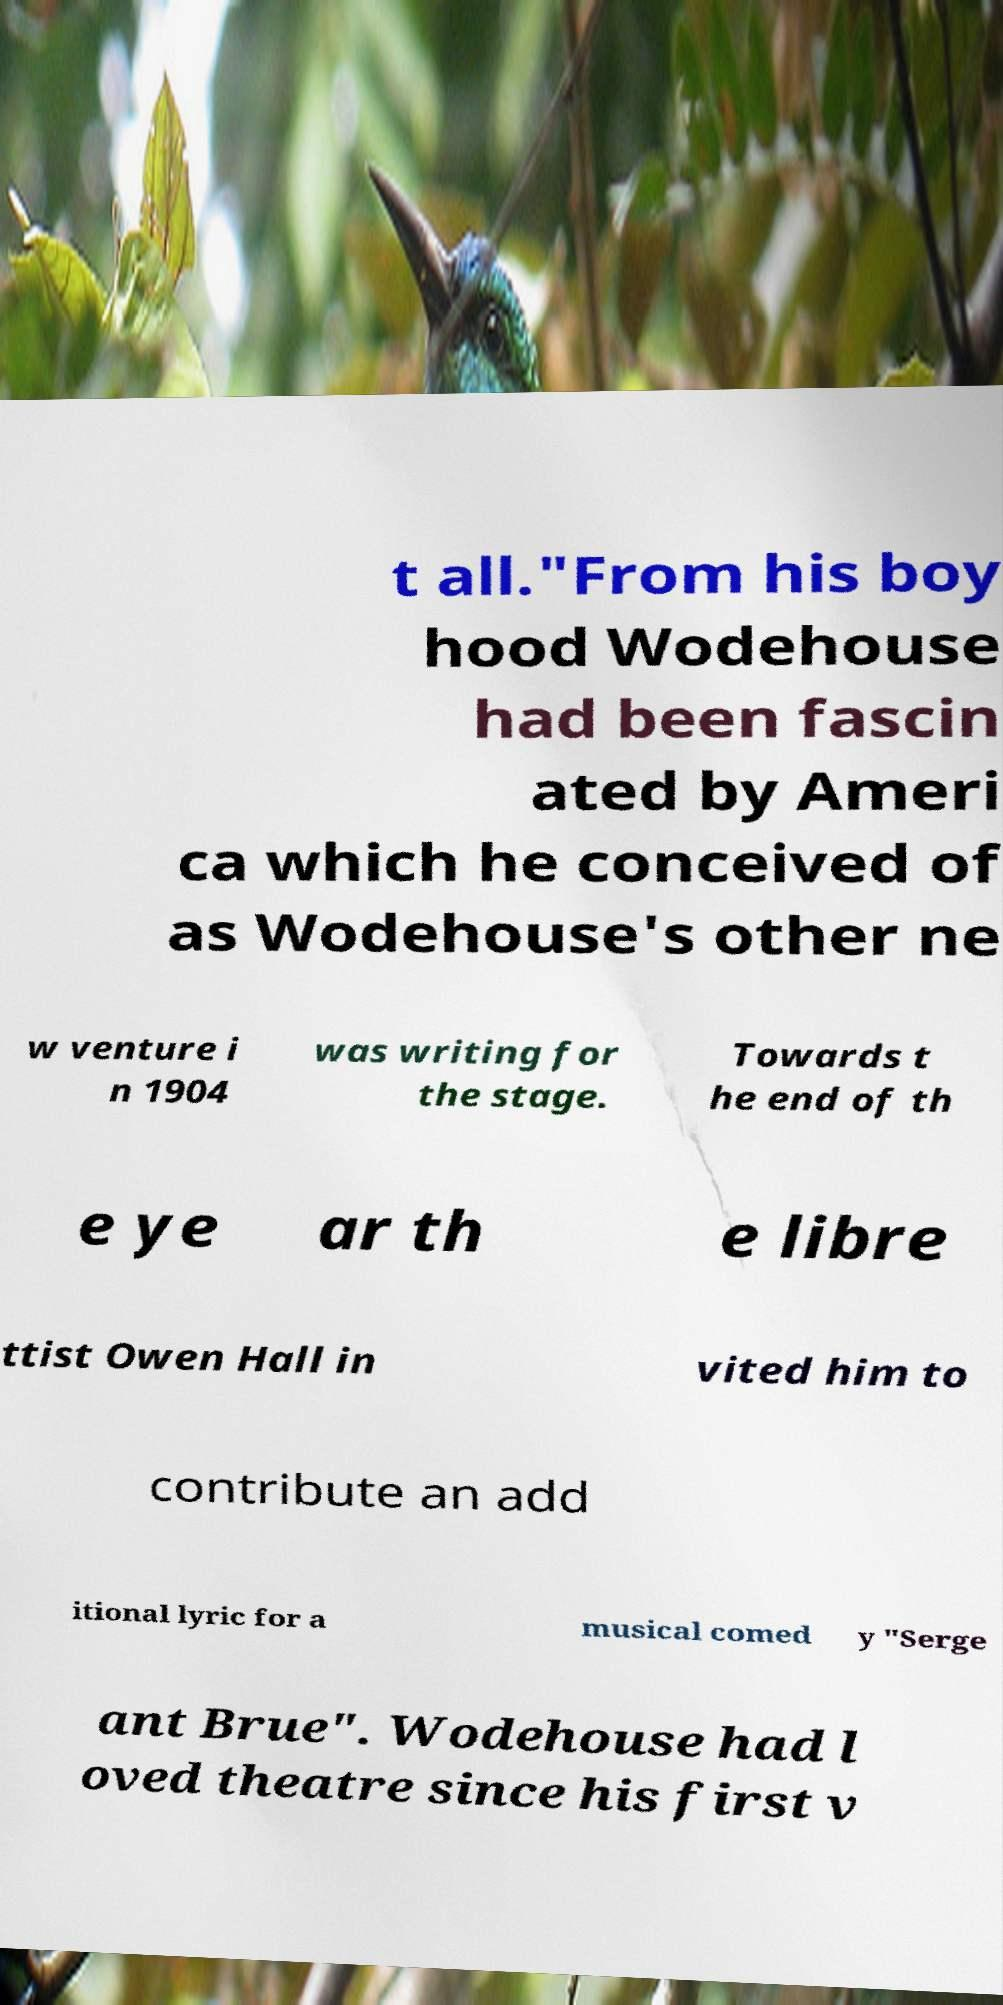Please read and relay the text visible in this image. What does it say? t all."From his boy hood Wodehouse had been fascin ated by Ameri ca which he conceived of as Wodehouse's other ne w venture i n 1904 was writing for the stage. Towards t he end of th e ye ar th e libre ttist Owen Hall in vited him to contribute an add itional lyric for a musical comed y "Serge ant Brue". Wodehouse had l oved theatre since his first v 